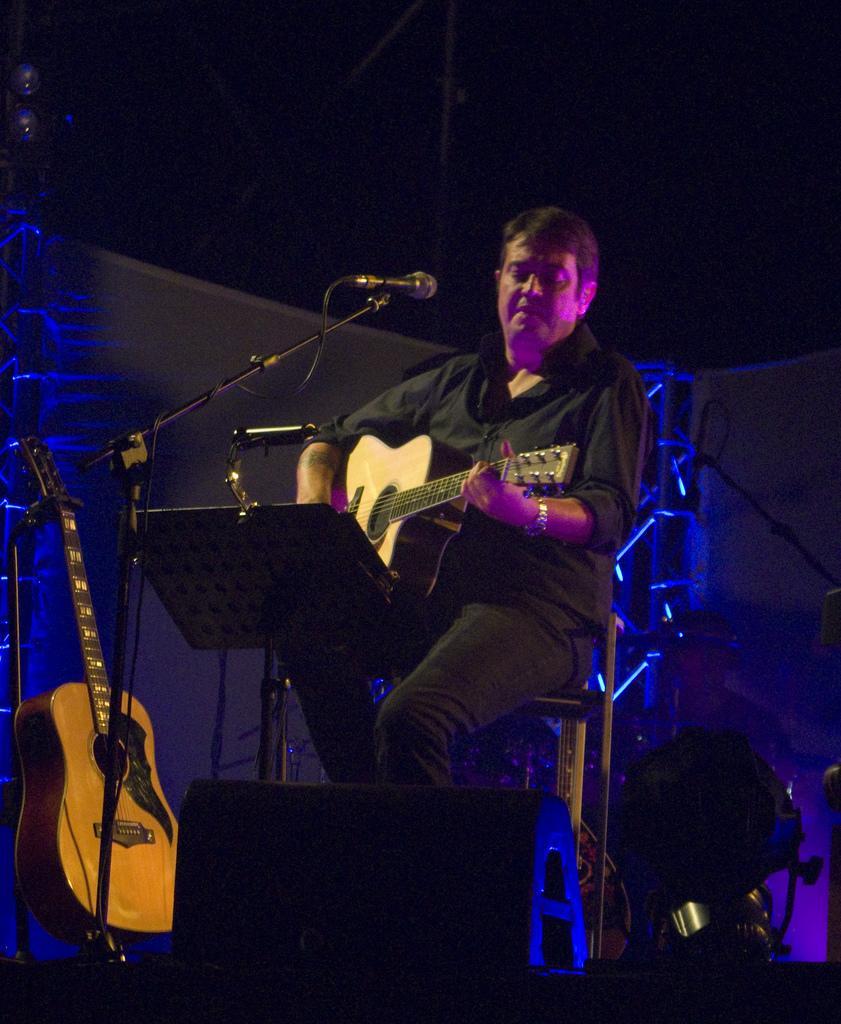In one or two sentences, can you explain what this image depicts? A man is sitting and playing guitar. 